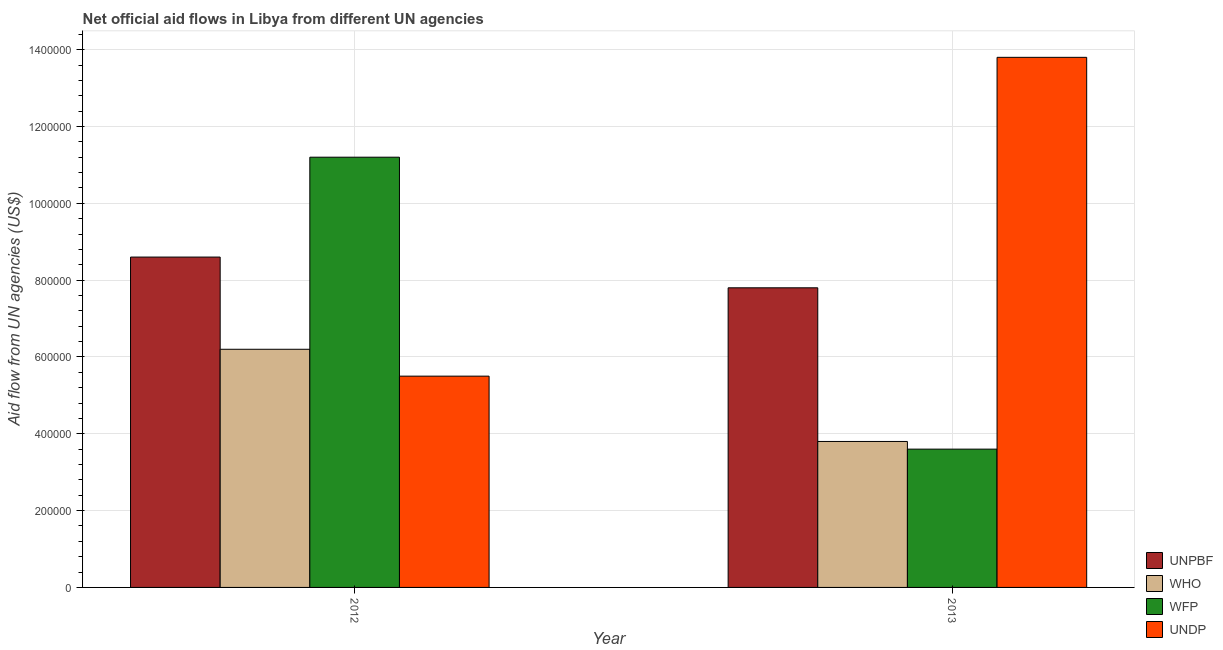How many different coloured bars are there?
Your response must be concise. 4. How many groups of bars are there?
Ensure brevity in your answer.  2. Are the number of bars on each tick of the X-axis equal?
Provide a succinct answer. Yes. How many bars are there on the 1st tick from the left?
Keep it short and to the point. 4. In how many cases, is the number of bars for a given year not equal to the number of legend labels?
Offer a very short reply. 0. What is the amount of aid given by undp in 2013?
Keep it short and to the point. 1.38e+06. Across all years, what is the maximum amount of aid given by unpbf?
Keep it short and to the point. 8.60e+05. Across all years, what is the minimum amount of aid given by undp?
Give a very brief answer. 5.50e+05. In which year was the amount of aid given by undp maximum?
Ensure brevity in your answer.  2013. In which year was the amount of aid given by unpbf minimum?
Keep it short and to the point. 2013. What is the total amount of aid given by unpbf in the graph?
Your answer should be very brief. 1.64e+06. What is the difference between the amount of aid given by who in 2012 and that in 2013?
Your response must be concise. 2.40e+05. What is the difference between the amount of aid given by unpbf in 2013 and the amount of aid given by undp in 2012?
Your response must be concise. -8.00e+04. What is the average amount of aid given by unpbf per year?
Ensure brevity in your answer.  8.20e+05. What is the ratio of the amount of aid given by undp in 2012 to that in 2013?
Offer a terse response. 0.4. Is the amount of aid given by who in 2012 less than that in 2013?
Offer a terse response. No. In how many years, is the amount of aid given by wfp greater than the average amount of aid given by wfp taken over all years?
Offer a very short reply. 1. What does the 1st bar from the left in 2013 represents?
Ensure brevity in your answer.  UNPBF. What does the 3rd bar from the right in 2012 represents?
Provide a succinct answer. WHO. Are all the bars in the graph horizontal?
Make the answer very short. No. How many years are there in the graph?
Your answer should be very brief. 2. What is the difference between two consecutive major ticks on the Y-axis?
Provide a succinct answer. 2.00e+05. Are the values on the major ticks of Y-axis written in scientific E-notation?
Provide a short and direct response. No. Where does the legend appear in the graph?
Ensure brevity in your answer.  Bottom right. How many legend labels are there?
Give a very brief answer. 4. What is the title of the graph?
Offer a very short reply. Net official aid flows in Libya from different UN agencies. Does "PFC gas" appear as one of the legend labels in the graph?
Your answer should be very brief. No. What is the label or title of the X-axis?
Provide a succinct answer. Year. What is the label or title of the Y-axis?
Your answer should be very brief. Aid flow from UN agencies (US$). What is the Aid flow from UN agencies (US$) in UNPBF in 2012?
Make the answer very short. 8.60e+05. What is the Aid flow from UN agencies (US$) of WHO in 2012?
Give a very brief answer. 6.20e+05. What is the Aid flow from UN agencies (US$) in WFP in 2012?
Make the answer very short. 1.12e+06. What is the Aid flow from UN agencies (US$) of UNDP in 2012?
Keep it short and to the point. 5.50e+05. What is the Aid flow from UN agencies (US$) in UNPBF in 2013?
Provide a succinct answer. 7.80e+05. What is the Aid flow from UN agencies (US$) of WFP in 2013?
Provide a succinct answer. 3.60e+05. What is the Aid flow from UN agencies (US$) in UNDP in 2013?
Offer a terse response. 1.38e+06. Across all years, what is the maximum Aid flow from UN agencies (US$) of UNPBF?
Make the answer very short. 8.60e+05. Across all years, what is the maximum Aid flow from UN agencies (US$) in WHO?
Make the answer very short. 6.20e+05. Across all years, what is the maximum Aid flow from UN agencies (US$) in WFP?
Provide a short and direct response. 1.12e+06. Across all years, what is the maximum Aid flow from UN agencies (US$) in UNDP?
Offer a terse response. 1.38e+06. Across all years, what is the minimum Aid flow from UN agencies (US$) of UNPBF?
Ensure brevity in your answer.  7.80e+05. Across all years, what is the minimum Aid flow from UN agencies (US$) in WHO?
Provide a succinct answer. 3.80e+05. Across all years, what is the minimum Aid flow from UN agencies (US$) of WFP?
Offer a very short reply. 3.60e+05. Across all years, what is the minimum Aid flow from UN agencies (US$) in UNDP?
Keep it short and to the point. 5.50e+05. What is the total Aid flow from UN agencies (US$) in UNPBF in the graph?
Offer a terse response. 1.64e+06. What is the total Aid flow from UN agencies (US$) of WHO in the graph?
Offer a very short reply. 1.00e+06. What is the total Aid flow from UN agencies (US$) in WFP in the graph?
Offer a very short reply. 1.48e+06. What is the total Aid flow from UN agencies (US$) of UNDP in the graph?
Ensure brevity in your answer.  1.93e+06. What is the difference between the Aid flow from UN agencies (US$) in UNPBF in 2012 and that in 2013?
Give a very brief answer. 8.00e+04. What is the difference between the Aid flow from UN agencies (US$) in WFP in 2012 and that in 2013?
Provide a short and direct response. 7.60e+05. What is the difference between the Aid flow from UN agencies (US$) of UNDP in 2012 and that in 2013?
Make the answer very short. -8.30e+05. What is the difference between the Aid flow from UN agencies (US$) of UNPBF in 2012 and the Aid flow from UN agencies (US$) of WFP in 2013?
Offer a very short reply. 5.00e+05. What is the difference between the Aid flow from UN agencies (US$) in UNPBF in 2012 and the Aid flow from UN agencies (US$) in UNDP in 2013?
Ensure brevity in your answer.  -5.20e+05. What is the difference between the Aid flow from UN agencies (US$) in WHO in 2012 and the Aid flow from UN agencies (US$) in WFP in 2013?
Your answer should be compact. 2.60e+05. What is the difference between the Aid flow from UN agencies (US$) of WHO in 2012 and the Aid flow from UN agencies (US$) of UNDP in 2013?
Keep it short and to the point. -7.60e+05. What is the average Aid flow from UN agencies (US$) of UNPBF per year?
Provide a succinct answer. 8.20e+05. What is the average Aid flow from UN agencies (US$) in WHO per year?
Make the answer very short. 5.00e+05. What is the average Aid flow from UN agencies (US$) in WFP per year?
Provide a succinct answer. 7.40e+05. What is the average Aid flow from UN agencies (US$) in UNDP per year?
Provide a succinct answer. 9.65e+05. In the year 2012, what is the difference between the Aid flow from UN agencies (US$) of WHO and Aid flow from UN agencies (US$) of WFP?
Offer a very short reply. -5.00e+05. In the year 2012, what is the difference between the Aid flow from UN agencies (US$) in WHO and Aid flow from UN agencies (US$) in UNDP?
Give a very brief answer. 7.00e+04. In the year 2012, what is the difference between the Aid flow from UN agencies (US$) of WFP and Aid flow from UN agencies (US$) of UNDP?
Give a very brief answer. 5.70e+05. In the year 2013, what is the difference between the Aid flow from UN agencies (US$) of UNPBF and Aid flow from UN agencies (US$) of WHO?
Keep it short and to the point. 4.00e+05. In the year 2013, what is the difference between the Aid flow from UN agencies (US$) of UNPBF and Aid flow from UN agencies (US$) of WFP?
Make the answer very short. 4.20e+05. In the year 2013, what is the difference between the Aid flow from UN agencies (US$) of UNPBF and Aid flow from UN agencies (US$) of UNDP?
Keep it short and to the point. -6.00e+05. In the year 2013, what is the difference between the Aid flow from UN agencies (US$) in WFP and Aid flow from UN agencies (US$) in UNDP?
Provide a short and direct response. -1.02e+06. What is the ratio of the Aid flow from UN agencies (US$) in UNPBF in 2012 to that in 2013?
Your answer should be very brief. 1.1. What is the ratio of the Aid flow from UN agencies (US$) of WHO in 2012 to that in 2013?
Ensure brevity in your answer.  1.63. What is the ratio of the Aid flow from UN agencies (US$) in WFP in 2012 to that in 2013?
Keep it short and to the point. 3.11. What is the ratio of the Aid flow from UN agencies (US$) of UNDP in 2012 to that in 2013?
Offer a very short reply. 0.4. What is the difference between the highest and the second highest Aid flow from UN agencies (US$) of WFP?
Keep it short and to the point. 7.60e+05. What is the difference between the highest and the second highest Aid flow from UN agencies (US$) in UNDP?
Your response must be concise. 8.30e+05. What is the difference between the highest and the lowest Aid flow from UN agencies (US$) in UNPBF?
Provide a short and direct response. 8.00e+04. What is the difference between the highest and the lowest Aid flow from UN agencies (US$) of WFP?
Offer a very short reply. 7.60e+05. What is the difference between the highest and the lowest Aid flow from UN agencies (US$) of UNDP?
Ensure brevity in your answer.  8.30e+05. 